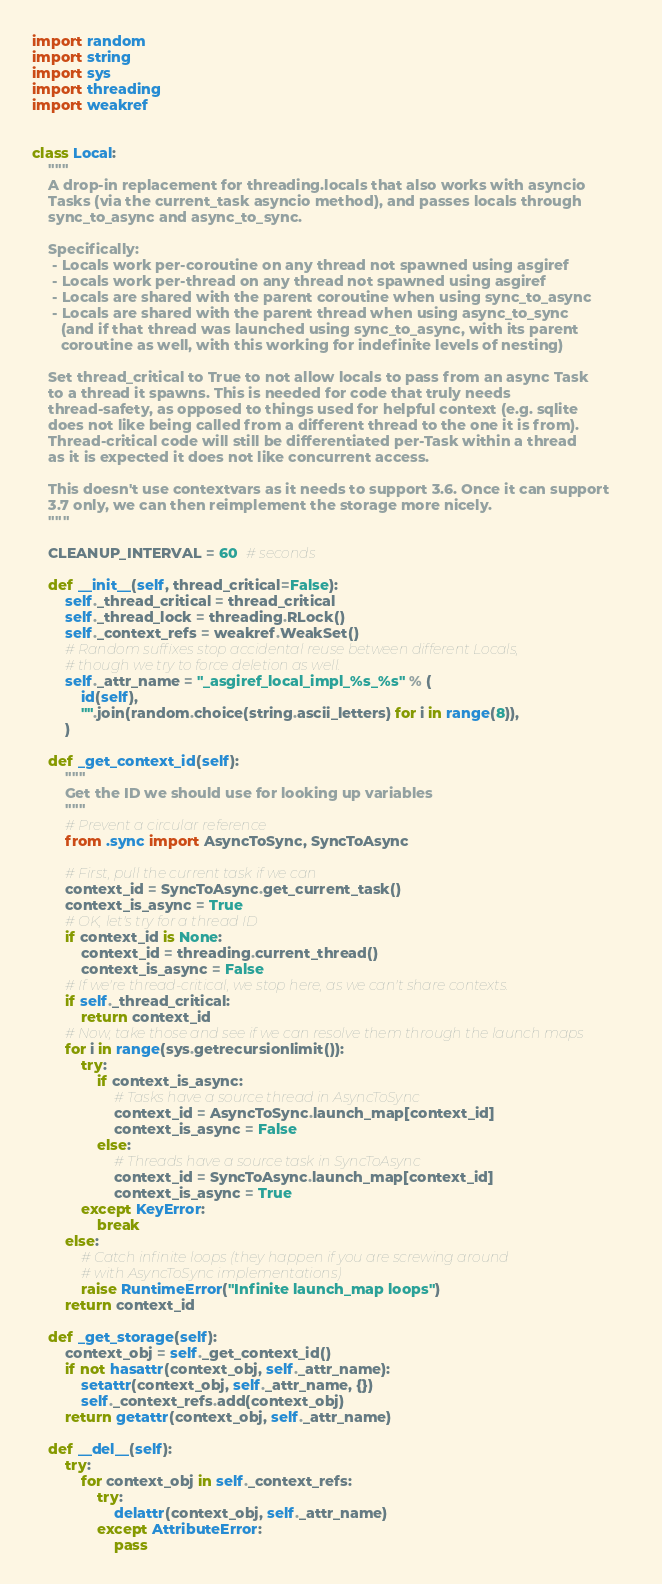Convert code to text. <code><loc_0><loc_0><loc_500><loc_500><_Python_>import random
import string
import sys
import threading
import weakref


class Local:
    """
    A drop-in replacement for threading.locals that also works with asyncio
    Tasks (via the current_task asyncio method), and passes locals through
    sync_to_async and async_to_sync.

    Specifically:
     - Locals work per-coroutine on any thread not spawned using asgiref
     - Locals work per-thread on any thread not spawned using asgiref
     - Locals are shared with the parent coroutine when using sync_to_async
     - Locals are shared with the parent thread when using async_to_sync
       (and if that thread was launched using sync_to_async, with its parent
       coroutine as well, with this working for indefinite levels of nesting)

    Set thread_critical to True to not allow locals to pass from an async Task
    to a thread it spawns. This is needed for code that truly needs
    thread-safety, as opposed to things used for helpful context (e.g. sqlite
    does not like being called from a different thread to the one it is from).
    Thread-critical code will still be differentiated per-Task within a thread
    as it is expected it does not like concurrent access.

    This doesn't use contextvars as it needs to support 3.6. Once it can support
    3.7 only, we can then reimplement the storage more nicely.
    """

    CLEANUP_INTERVAL = 60  # seconds

    def __init__(self, thread_critical=False):
        self._thread_critical = thread_critical
        self._thread_lock = threading.RLock()
        self._context_refs = weakref.WeakSet()
        # Random suffixes stop accidental reuse between different Locals,
        # though we try to force deletion as well.
        self._attr_name = "_asgiref_local_impl_%s_%s" % (
            id(self),
            "".join(random.choice(string.ascii_letters) for i in range(8)),
        )

    def _get_context_id(self):
        """
        Get the ID we should use for looking up variables
        """
        # Prevent a circular reference
        from .sync import AsyncToSync, SyncToAsync

        # First, pull the current task if we can
        context_id = SyncToAsync.get_current_task()
        context_is_async = True
        # OK, let's try for a thread ID
        if context_id is None:
            context_id = threading.current_thread()
            context_is_async = False
        # If we're thread-critical, we stop here, as we can't share contexts.
        if self._thread_critical:
            return context_id
        # Now, take those and see if we can resolve them through the launch maps
        for i in range(sys.getrecursionlimit()):
            try:
                if context_is_async:
                    # Tasks have a source thread in AsyncToSync
                    context_id = AsyncToSync.launch_map[context_id]
                    context_is_async = False
                else:
                    # Threads have a source task in SyncToAsync
                    context_id = SyncToAsync.launch_map[context_id]
                    context_is_async = True
            except KeyError:
                break
        else:
            # Catch infinite loops (they happen if you are screwing around
            # with AsyncToSync implementations)
            raise RuntimeError("Infinite launch_map loops")
        return context_id

    def _get_storage(self):
        context_obj = self._get_context_id()
        if not hasattr(context_obj, self._attr_name):
            setattr(context_obj, self._attr_name, {})
            self._context_refs.add(context_obj)
        return getattr(context_obj, self._attr_name)

    def __del__(self):
        try:
            for context_obj in self._context_refs:
                try:
                    delattr(context_obj, self._attr_name)
                except AttributeError:
                    pass</code> 